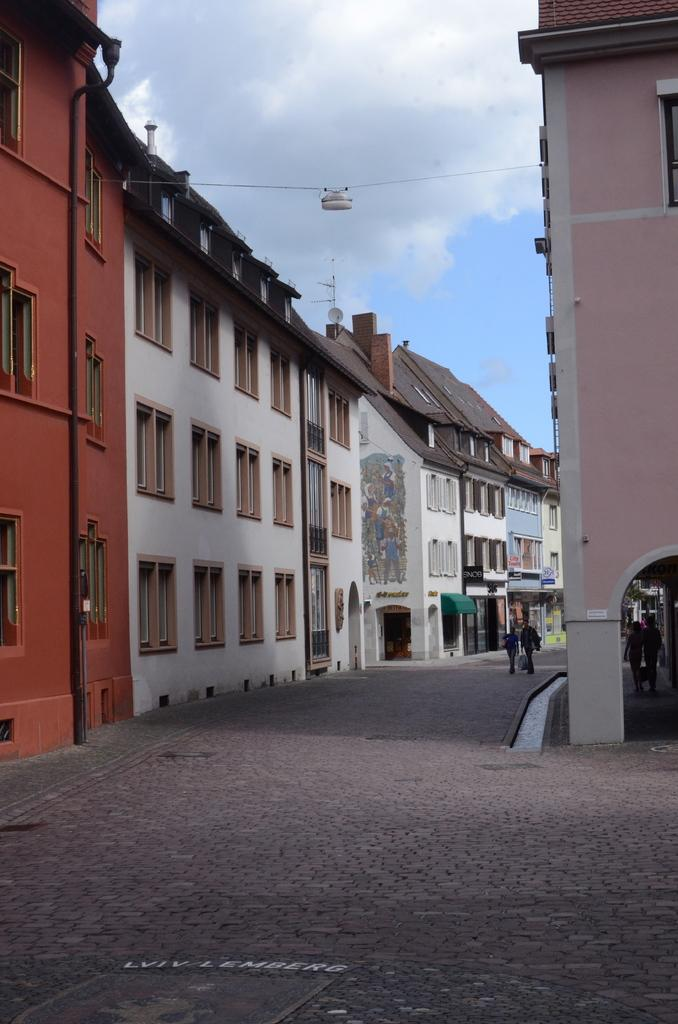What is the main feature of the image? There is a road in the image. What are the people in the image doing? People are walking on the road. What else can be seen in the image besides the road and people? There are wires visible in the image, and there are buildings and the sky in the background. What is the condition of the sky in the image? The sky is visible in the background, and clouds are present. Can you hear the guitar being played in the image? There is no guitar present in the image, so it cannot be heard. What type of waves can be seen in the image? There are no waves visible in the image; it features a road with people walking and other elements mentioned in the conversation. 